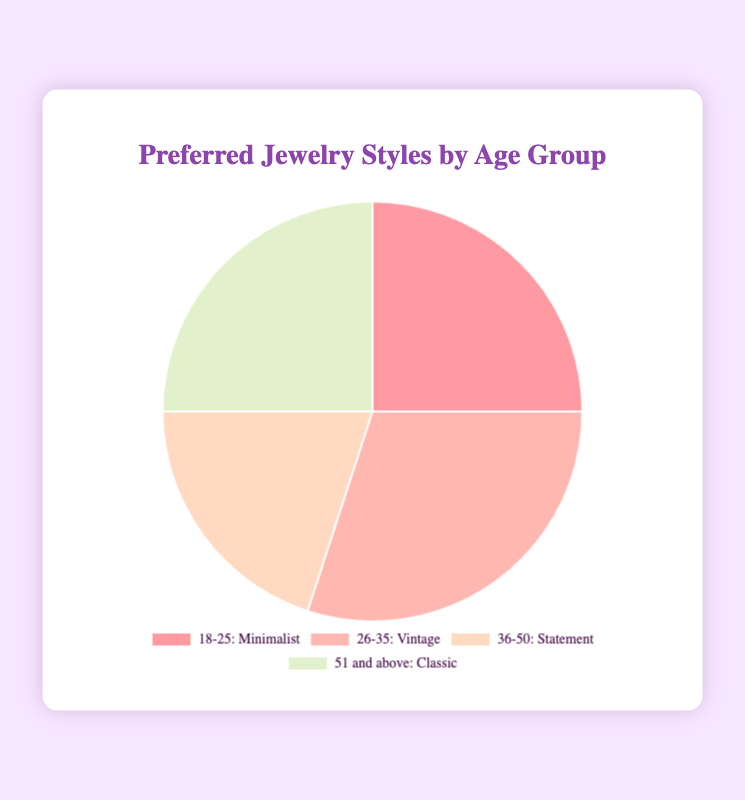what is the most popular jewelry style among the 26-35 age group? The chart shows age groups and their corresponding preferred styles with percentages. For the 26-35 age group, the preferred style is "Vintage".
Answer: Vintage what is the combined percentage of Minimalist and Classic styles? From the chart, the percentages for Minimalist and Classic are 25% each. Adding them together gives 25% + 25% = 50%.
Answer: 50% which age group has the least preference for their jewelry style? Looking at the chart, the age group 36-50 has a 20% preference for Statement style, which is the smallest among all groups.
Answer: 36-50 how do Minimalist and Statement styles compare in terms of preference? Minimalist style has a preference percentage of 25%, while Statement style has 20%. Therefore, Minimalist is more preferred than Statement.
Answer: Minimalist is more preferred which style is equally preferred among two different age groups? From the chart, both Minimalist and Classic styles have 25% preference, indicating that two age groups prefer these styles equally. Upon closer inspection, Minimalist is preferred by the 18-25 age group and Classic by the 51 and above age group.
Answer: Minimalist and Classic if the total number of survey respondents is 400, how many prefer Classic style? With Classic style at 25%, you multiply 25 by 4 (because 1% equals 4 respondents in a group of 400) to get 25 * 4 = 100 respondents.
Answer: 100 which age group is represented by the color red in the chart? Visually, the color red corresponds to the 18-25 age group preferring the Minimalist style.
Answer: 18-25 what is the difference in preference between Vintage and Statement styles? The preference for Vintage style is 30%, while Statement style stands at 20%. The difference is calculated as 30% - 20% = 10%.
Answer: 10% how much more popular is the Vintage style compared to the Minimalist style? Vintage style has 30% preference, and Minimalist style has 25%. The difference is 30% - 25% = 5%.
Answer: 5% how are the percentages distributed among the different age groups? The percentages given in the chart are 25% for 18-25, 30% for 26-35, 20% for 36-50, and 25% for 51 and above.
Answer: 25%, 30%, 20%, 25% 